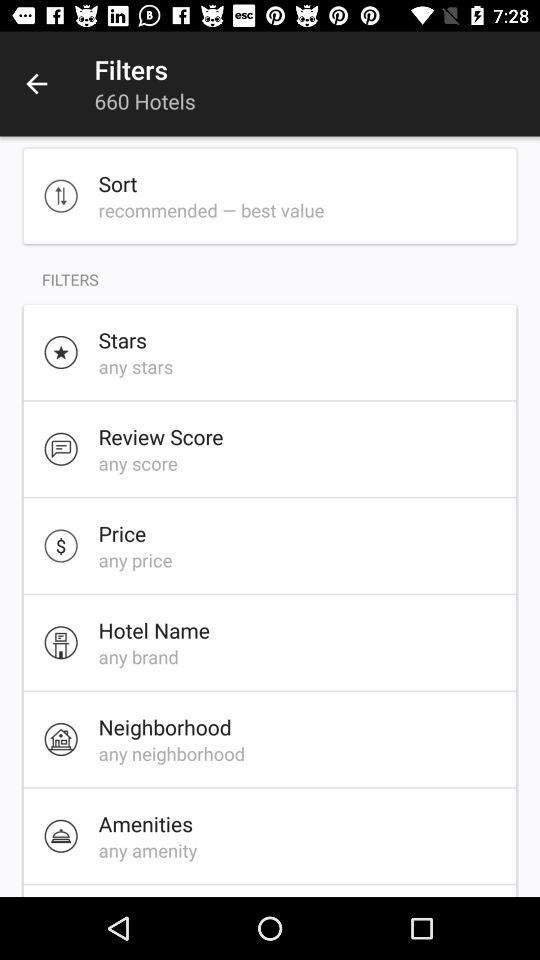What is the selected review score? The selected review score is "any score". 